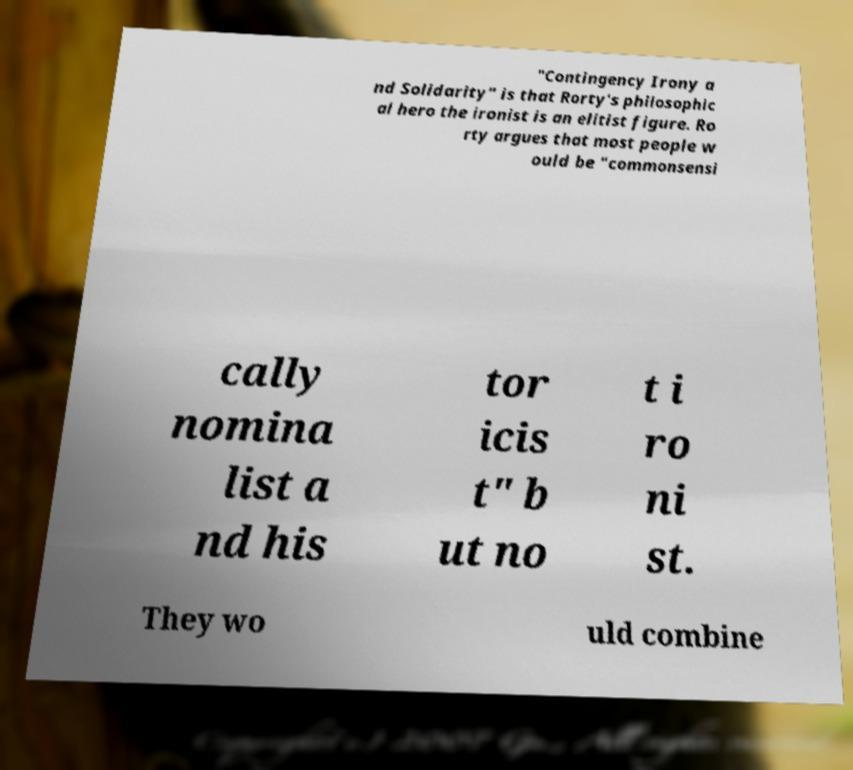Please identify and transcribe the text found in this image. "Contingency Irony a nd Solidarity" is that Rorty's philosophic al hero the ironist is an elitist figure. Ro rty argues that most people w ould be "commonsensi cally nomina list a nd his tor icis t" b ut no t i ro ni st. They wo uld combine 